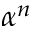Convert formula to latex. <formula><loc_0><loc_0><loc_500><loc_500>\alpha ^ { n }</formula> 